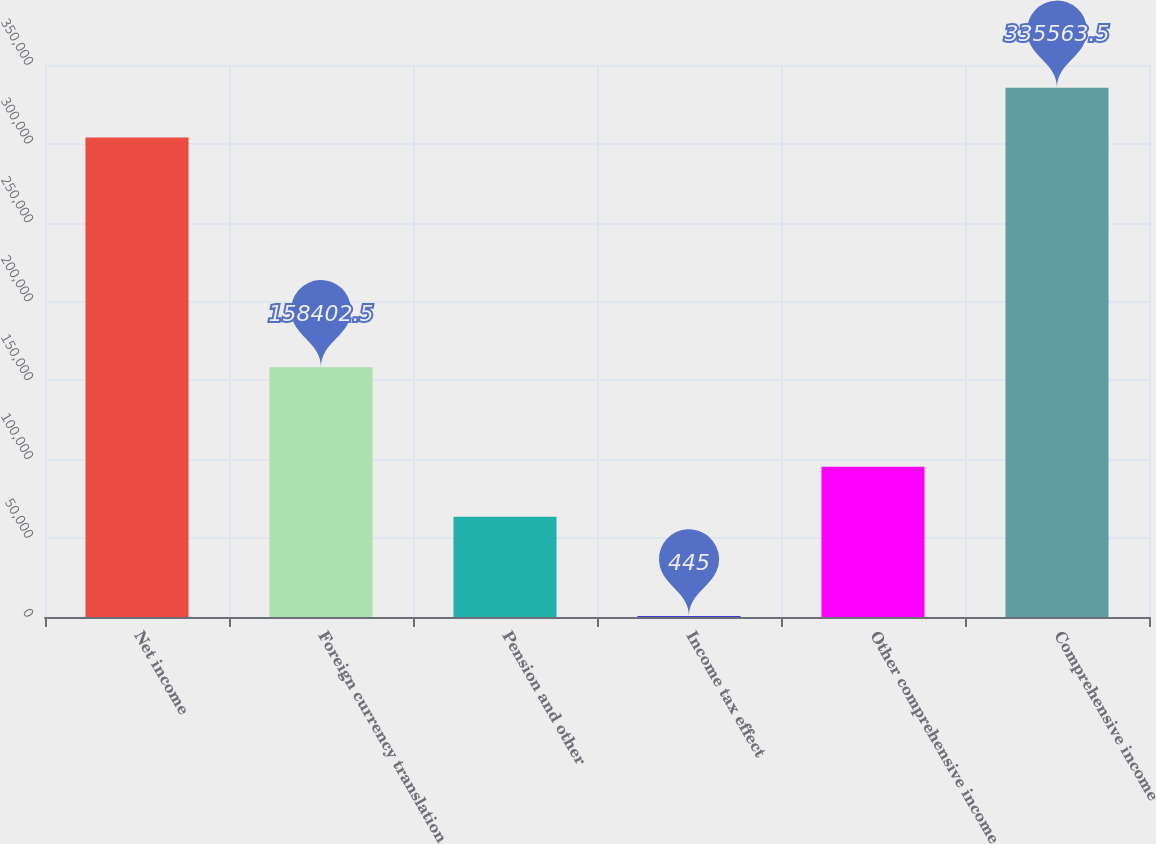Convert chart to OTSL. <chart><loc_0><loc_0><loc_500><loc_500><bar_chart><fcel>Net income<fcel>Foreign currency translation<fcel>Pension and other<fcel>Income tax effect<fcel>Other comprehensive income<fcel>Comprehensive income<nl><fcel>303972<fcel>158402<fcel>63628<fcel>445<fcel>95219.5<fcel>335564<nl></chart> 